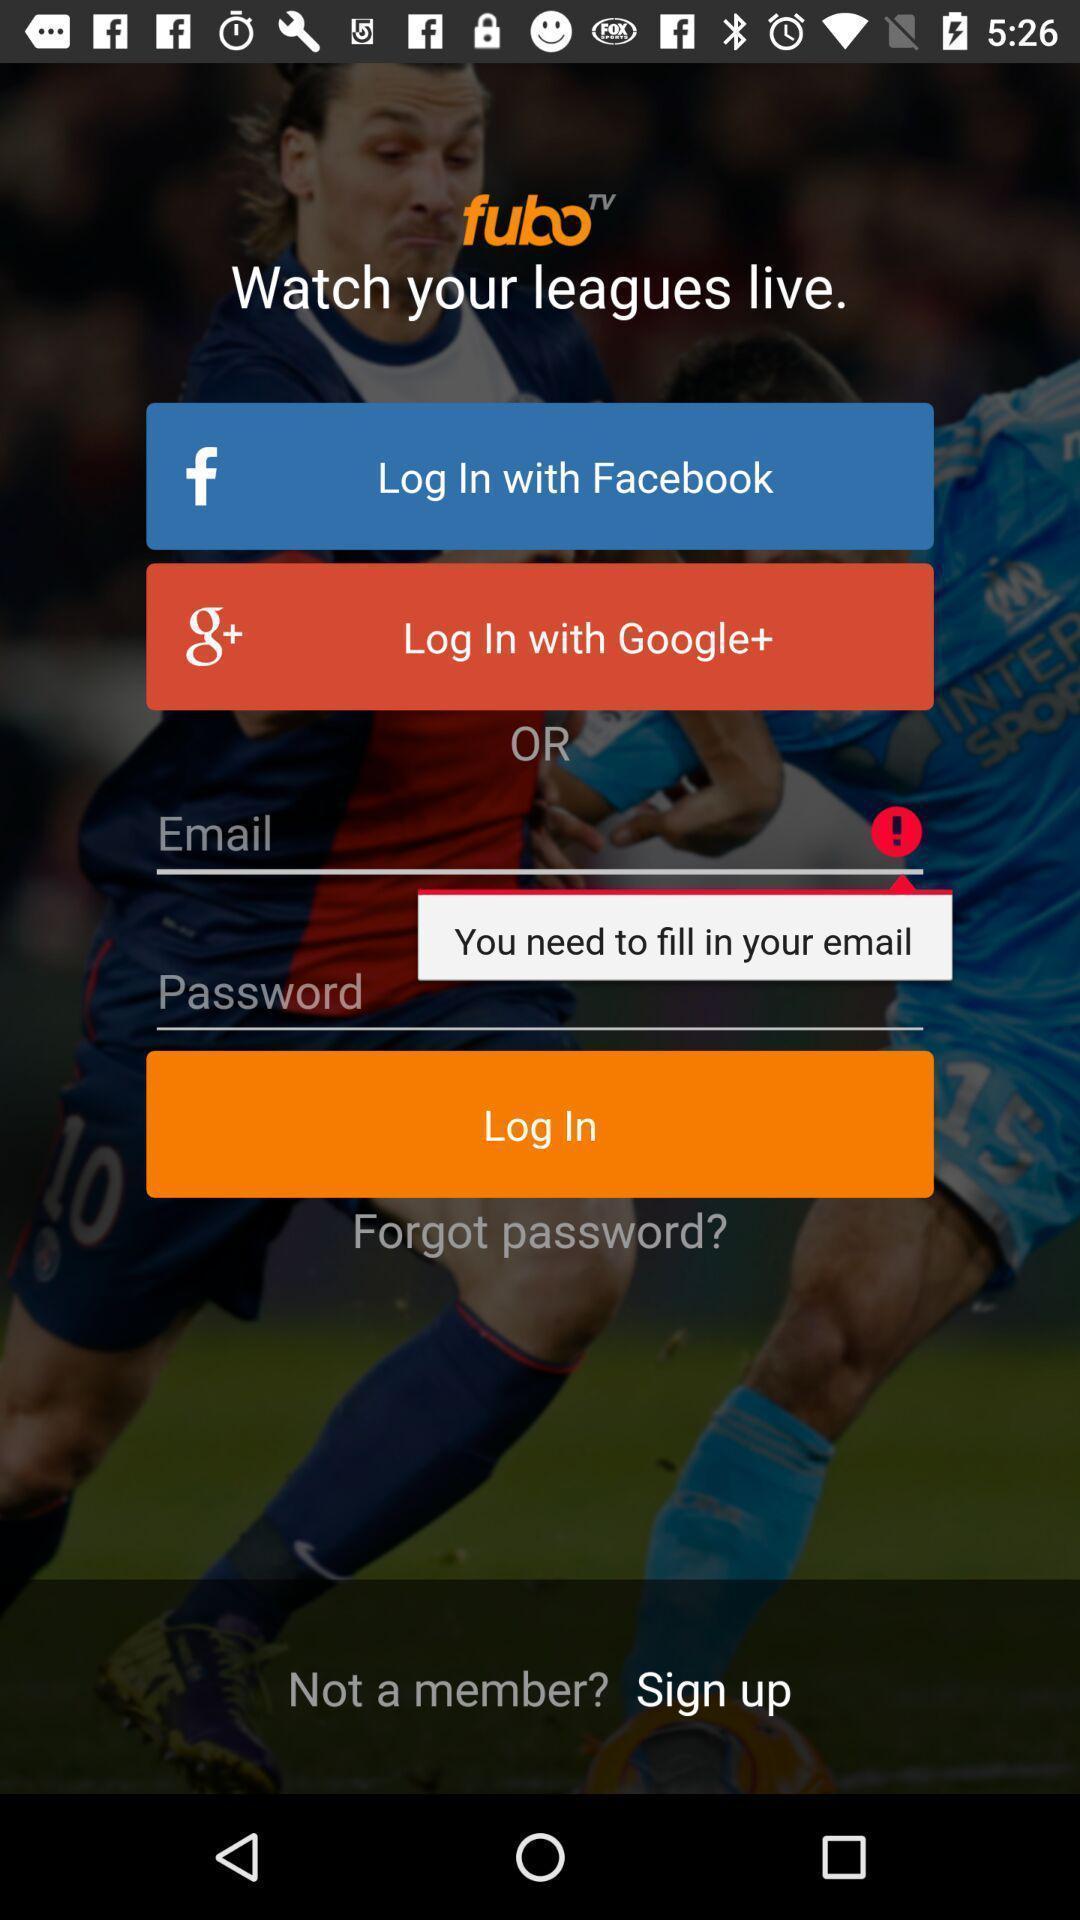Explain the elements present in this screenshot. Screen display log in page. 